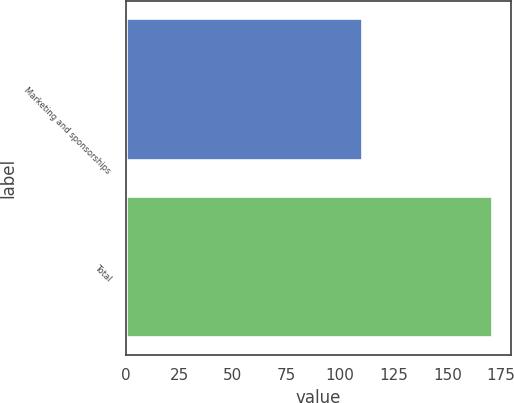Convert chart. <chart><loc_0><loc_0><loc_500><loc_500><bar_chart><fcel>Marketing and sponsorships<fcel>Total<nl><fcel>110<fcel>171<nl></chart> 